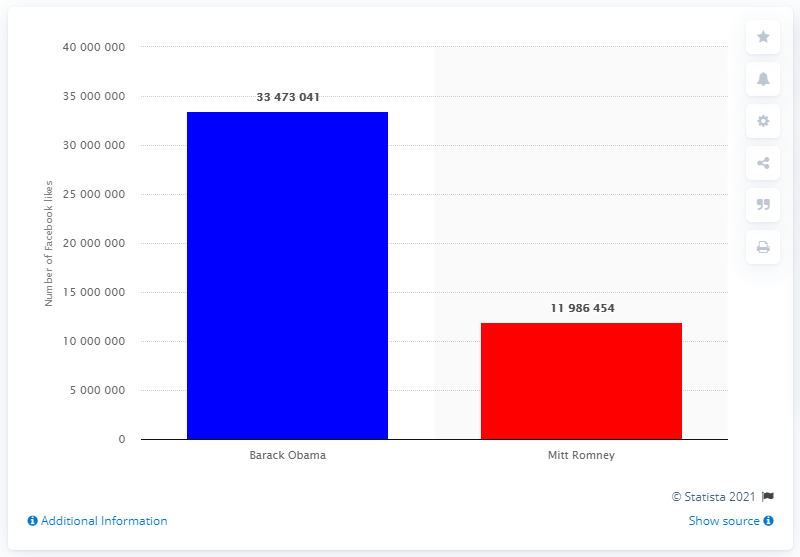Point out several critical features in this image. Obama has 33,473,041 Facebook likes, which is more than Mitt Romney's 21,451,827 likes. 